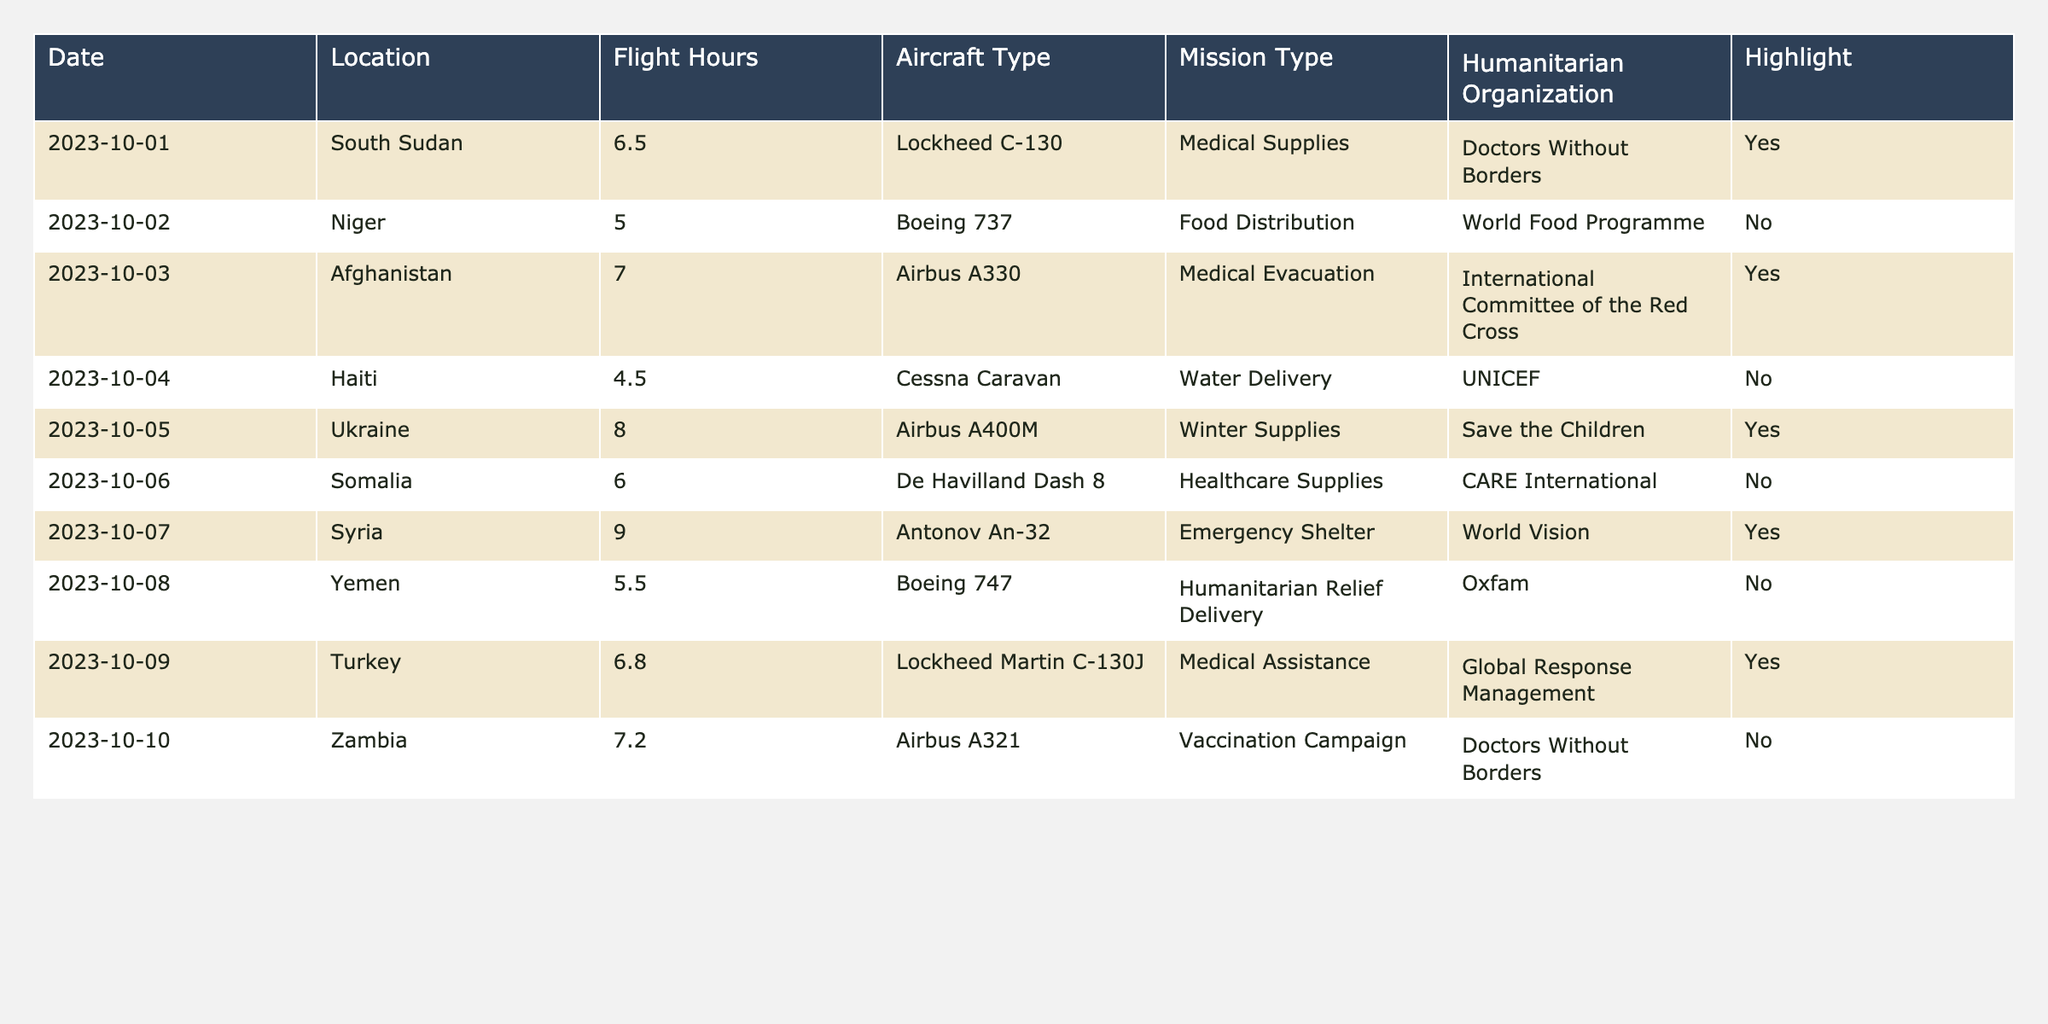What is the total number of flight hours conducted on highlighted missions? The highlighted missions have flight hours of 6.5 (South Sudan), 7.0 (Afghanistan), 8.0 (Ukraine), 9.0 (Syria), and 6.8 (Turkey). Summing these gives 6.5 + 7.0 + 8.0 + 9.0 + 6.8 = 37.3.
Answer: 37.3 Which aircraft type was used for the longest mission? The mission with the longest flight hours is in Syria with 9.0 hours, where the aircraft type used is Antonov An-32.
Answer: Antonov An-32 Did any missions occur in Yemen, and if so, what was the flight hour? Yes, there is a mission in Yemen on 2023-10-08 with a flight hour of 5.5.
Answer: Yes, 5.5 hours What is the average flight hour for all missions conducted? The total flight hours from all missions is 6.5 + 5.0 + 7.0 + 4.5 + 8.0 + 6.0 + 9.0 + 5.5 + 6.8 + 7.2 = 58.5 hours. There are 10 missions, so the average is 58.5/10 = 5.85.
Answer: 5.85 How many organizations were involved in the missions that had highlighted values? The highlighted missions were conducted by Doctors Without Borders (South Sudan), International Committee of the Red Cross (Afghanistan), Save the Children (Ukraine), World Vision (Syria), and Global Response Management (Turkey). This gives a total of 5 distinct organizations.
Answer: 5 What was the shortest flight hour recorded in the table, and for which mission? The shortest flight hour recorded is 4.5 hours, which was for the mission in Haiti.
Answer: 4.5 hours in Haiti Is there a mission in October with flight hours greater than 8? Yes, the mission in Syria on 2023-10-07 has flight hours of 9.0, which is greater than 8.
Answer: Yes Was the mission in South Sudan geared towards medical supplies, and how many hours did it fly? Yes, the mission in South Sudan was for medical supplies and it recorded 6.5 flight hours.
Answer: Yes, 6.5 hours What is the total number of days where the flight hours exceeded 6 hours? The flights exceeding 6 hours happened on 2023-10-01 (6.5), 2023-10-03 (7.0), 2023-10-05 (8.0), 2023-10-07 (9.0), and 2023-10-09 (6.8), which adds up to 5 days.
Answer: 5 days Which mission had the highest flight hours and what was the aircraft type used? The highest flight hours were recorded on 2023-10-07 in Syria with 9.0 hours using the Antonov An-32.
Answer: Antonov An-32 with 9.0 hours 